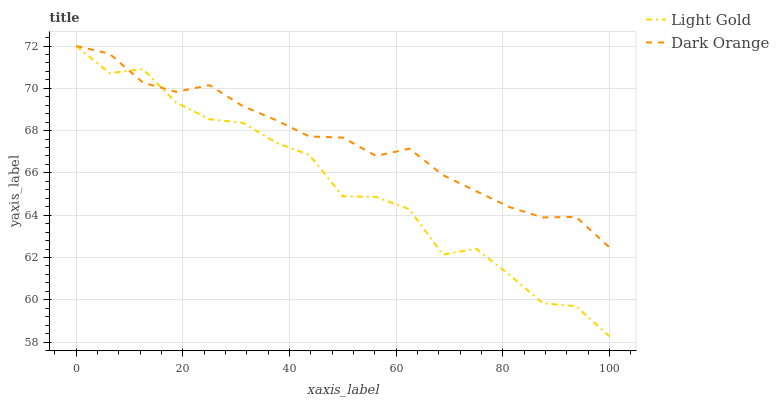Does Light Gold have the maximum area under the curve?
Answer yes or no. No. Is Light Gold the smoothest?
Answer yes or no. No. 